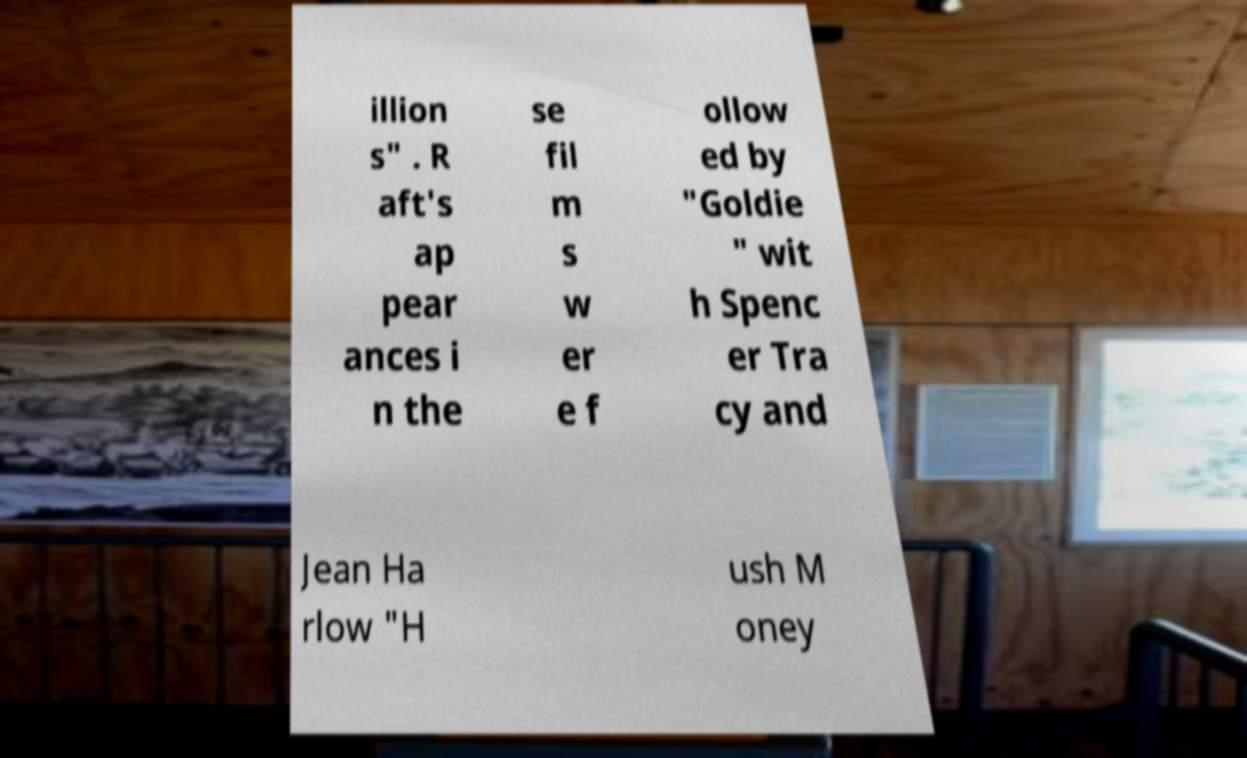Could you assist in decoding the text presented in this image and type it out clearly? illion s" . R aft's ap pear ances i n the se fil m s w er e f ollow ed by "Goldie " wit h Spenc er Tra cy and Jean Ha rlow "H ush M oney 